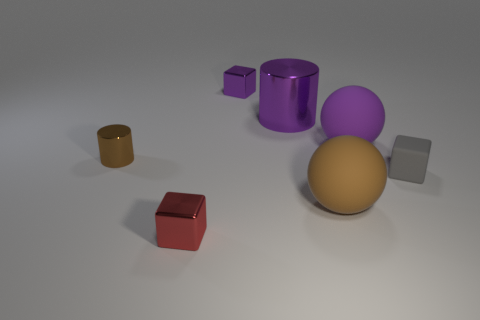Add 1 small gray metallic spheres. How many objects exist? 8 Subtract all cylinders. How many objects are left? 5 Subtract 1 red blocks. How many objects are left? 6 Subtract all purple cylinders. Subtract all large brown spheres. How many objects are left? 5 Add 4 brown metal things. How many brown metal things are left? 5 Add 4 purple cylinders. How many purple cylinders exist? 5 